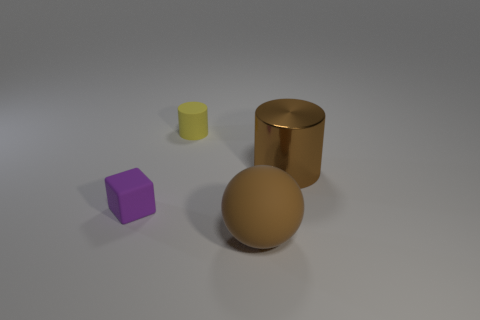What is the color of the matte object that is both in front of the metallic cylinder and left of the big matte object?
Offer a very short reply. Purple. What is the tiny object that is in front of the yellow cylinder made of?
Make the answer very short. Rubber. Is there a small blue thing that has the same shape as the tiny purple matte object?
Offer a terse response. No. How many other things are the same shape as the small purple object?
Give a very brief answer. 0. There is a big brown rubber object; is it the same shape as the small object in front of the small yellow rubber cylinder?
Offer a very short reply. No. Is there any other thing that is the same material as the sphere?
Give a very brief answer. Yes. There is another yellow thing that is the same shape as the shiny object; what is it made of?
Provide a succinct answer. Rubber. How many large objects are metal things or yellow cylinders?
Your response must be concise. 1. Are there fewer big metal objects behind the brown rubber thing than small blocks that are behind the big brown cylinder?
Ensure brevity in your answer.  No. What number of things are large cylinders or tiny blocks?
Your answer should be very brief. 2. 